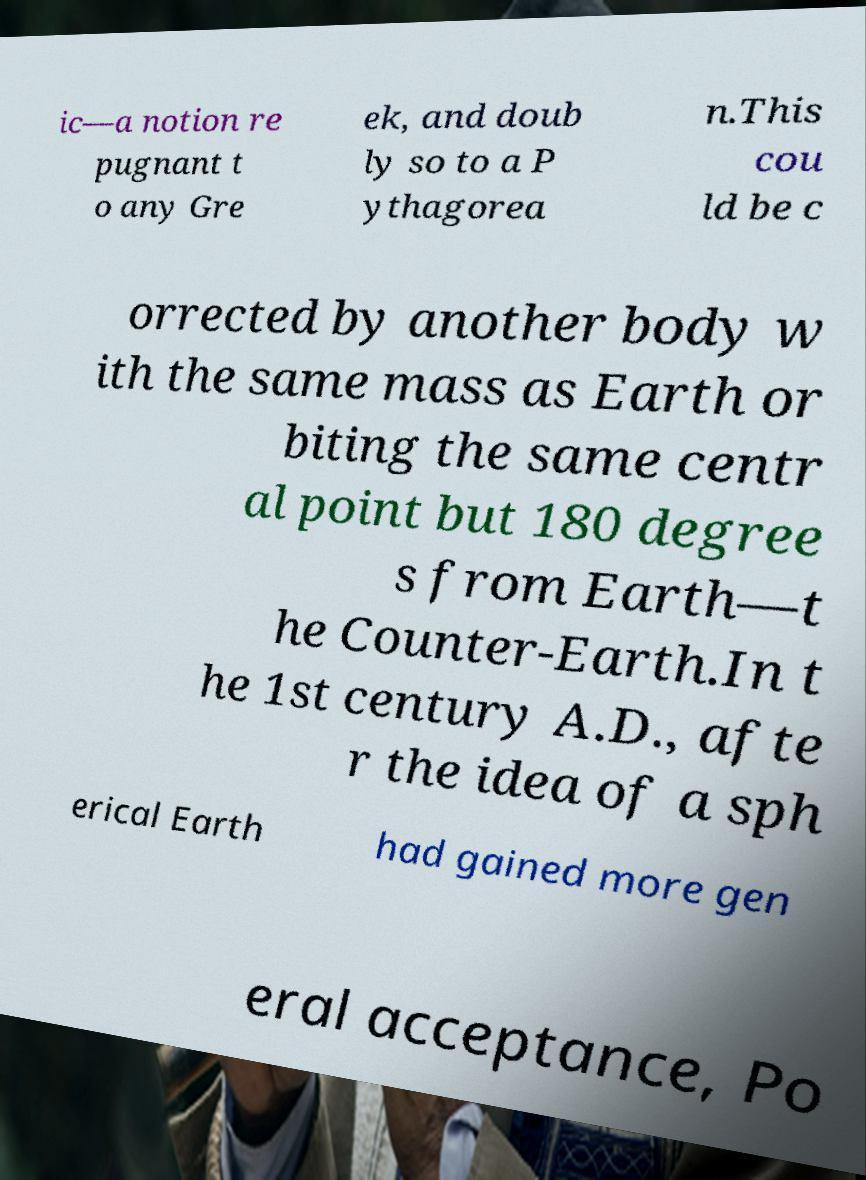Could you assist in decoding the text presented in this image and type it out clearly? ic—a notion re pugnant t o any Gre ek, and doub ly so to a P ythagorea n.This cou ld be c orrected by another body w ith the same mass as Earth or biting the same centr al point but 180 degree s from Earth—t he Counter-Earth.In t he 1st century A.D., afte r the idea of a sph erical Earth had gained more gen eral acceptance, Po 